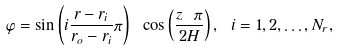<formula> <loc_0><loc_0><loc_500><loc_500>\varphi = \sin \left ( i \frac { r - r _ { i } } { r _ { o } - r _ { i } } \pi \right ) \ \cos \left ( \frac { z \ \pi } { 2 H } \right ) , \ i = 1 , 2 , \dots , N _ { r } ,</formula> 